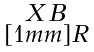Convert formula to latex. <formula><loc_0><loc_0><loc_500><loc_500>\begin{smallmatrix} X \, B \\ [ 1 m m ] R \end{smallmatrix}</formula> 